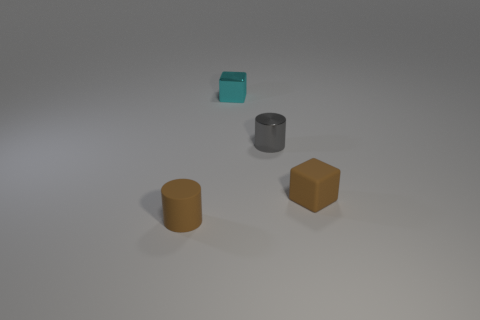Do the rubber block and the rubber cylinder have the same color?
Provide a succinct answer. Yes. Does the object that is right of the small gray shiny cylinder have the same color as the rubber cylinder?
Your answer should be very brief. Yes. Are there any other small metallic things of the same shape as the gray metal thing?
Make the answer very short. No. The block that is the same size as the cyan object is what color?
Your response must be concise. Brown. There is a brown thing that is behind the small rubber cylinder; how big is it?
Your response must be concise. Small. There is a tiny metal object that is in front of the small metallic block; is there a small gray metal cylinder that is in front of it?
Ensure brevity in your answer.  No. Does the small thing that is to the left of the tiny cyan block have the same material as the brown block?
Provide a short and direct response. Yes. What number of tiny objects are both behind the small rubber cube and on the left side of the small gray metallic thing?
Ensure brevity in your answer.  1. What number of cylinders are made of the same material as the brown cube?
Your answer should be very brief. 1. There is a tiny cube that is made of the same material as the gray thing; what color is it?
Provide a succinct answer. Cyan. 